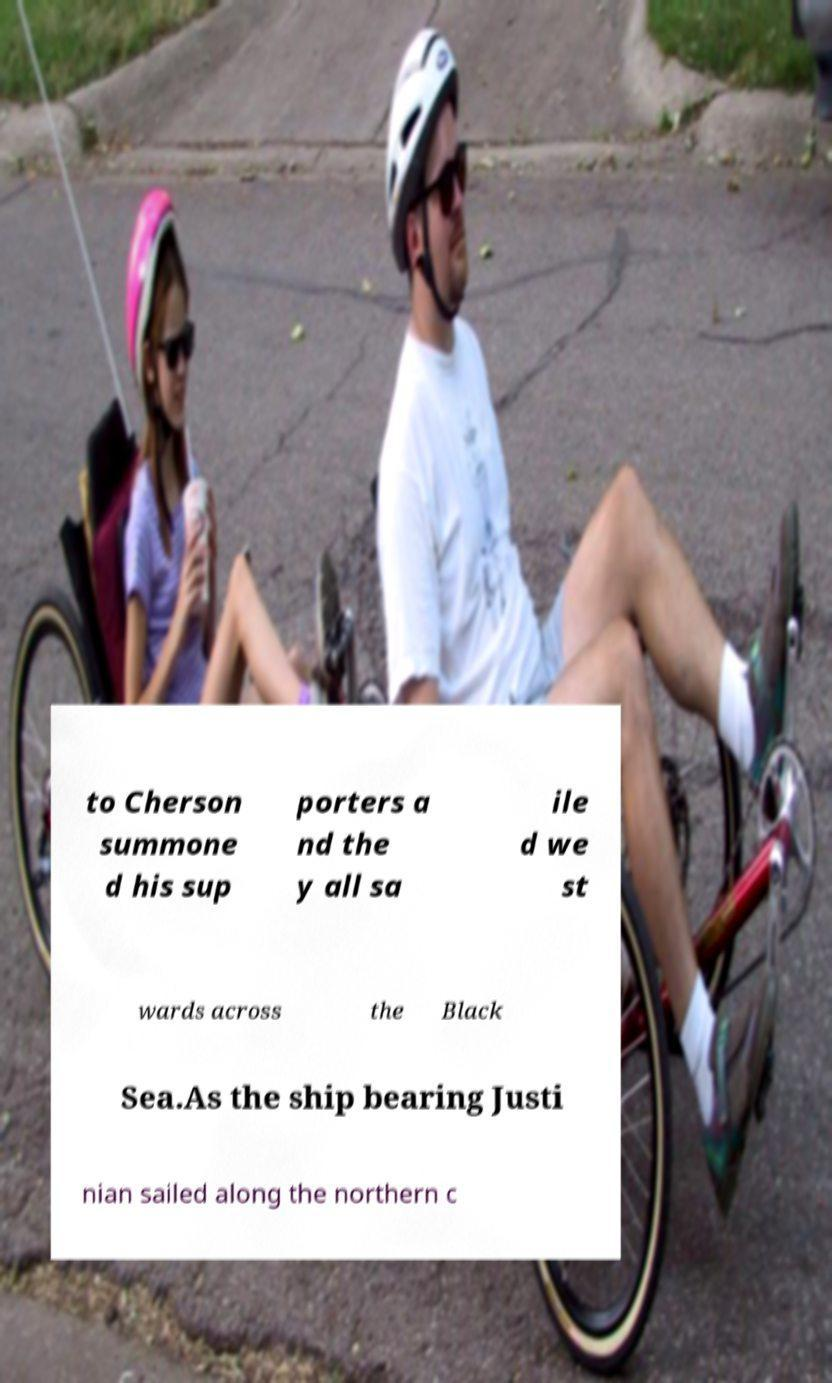For documentation purposes, I need the text within this image transcribed. Could you provide that? to Cherson summone d his sup porters a nd the y all sa ile d we st wards across the Black Sea.As the ship bearing Justi nian sailed along the northern c 